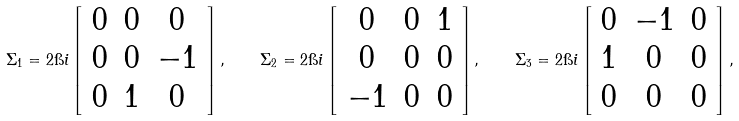Convert formula to latex. <formula><loc_0><loc_0><loc_500><loc_500>\Sigma _ { 1 } = 2 \i i \left [ \begin{array} { c c c } 0 & 0 & 0 \\ 0 & 0 & - 1 \\ 0 & 1 & 0 \end{array} \right ] , \quad \Sigma _ { 2 } = 2 \i i \left [ \begin{array} { c c c } 0 & 0 & 1 \\ 0 & 0 & 0 \\ - 1 & 0 & 0 \end{array} \right ] , \quad \Sigma _ { 3 } = 2 \i i \left [ \begin{array} { c c c } 0 & - 1 & 0 \\ 1 & 0 & 0 \\ 0 & 0 & 0 \end{array} \right ] ,</formula> 